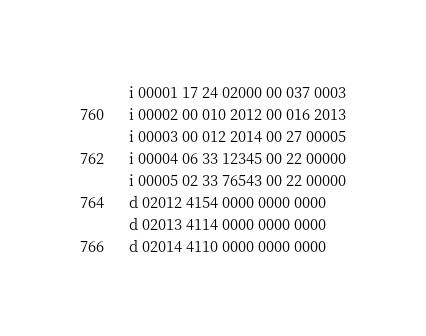Convert code to text. <code><loc_0><loc_0><loc_500><loc_500><_Octave_>i 00001 17 24 02000 00 037 0003
i 00002 00 010 2012 00 016 2013
i 00003 00 012 2014 00 27 00005
i 00004 06 33 12345 00 22 00000
i 00005 02 33 76543 00 22 00000
d 02012 4154 0000 0000 0000
d 02013 4114 0000 0000 0000
d 02014 4110 0000 0000 0000
</code> 